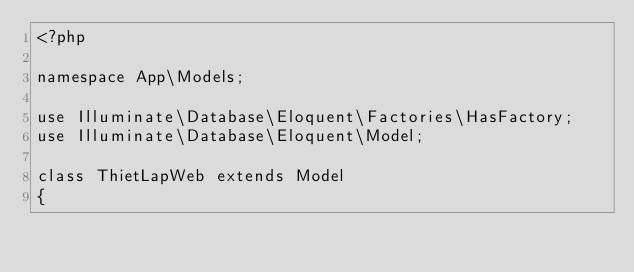<code> <loc_0><loc_0><loc_500><loc_500><_PHP_><?php

namespace App\Models;

use Illuminate\Database\Eloquent\Factories\HasFactory;
use Illuminate\Database\Eloquent\Model;

class ThietLapWeb extends Model
{</code> 